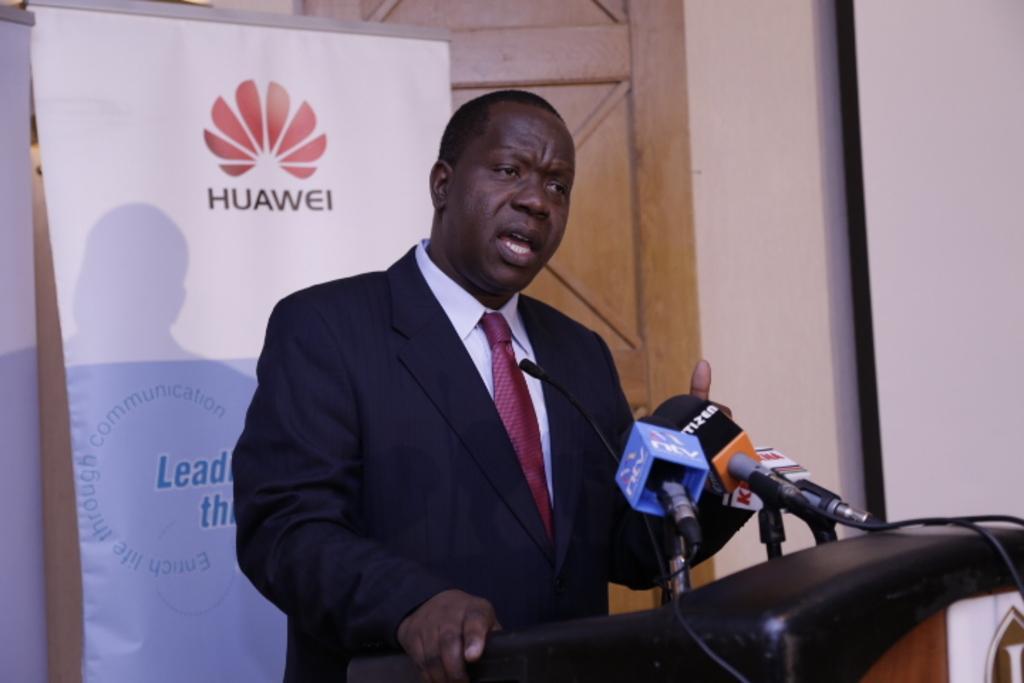Describe this image in one or two sentences. Here we can see a man standing at the podium and talking on the mikes which are on podium. In the background there are hoardings,wall,door and a screen 